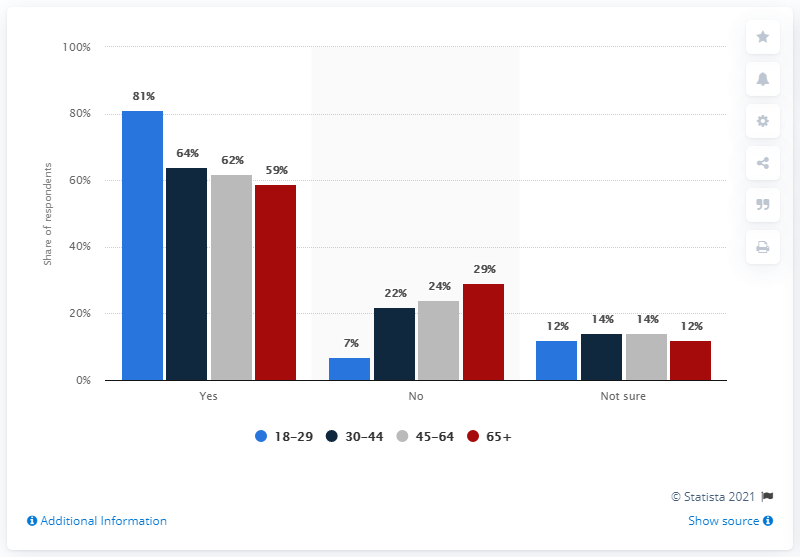Could you tell me which age group showed the highest agreement? Certainly, the age group with the highest percentage of 'Yes' responses is the 18-29 years category, as indicated by the blue bar reaching up to 81%. 